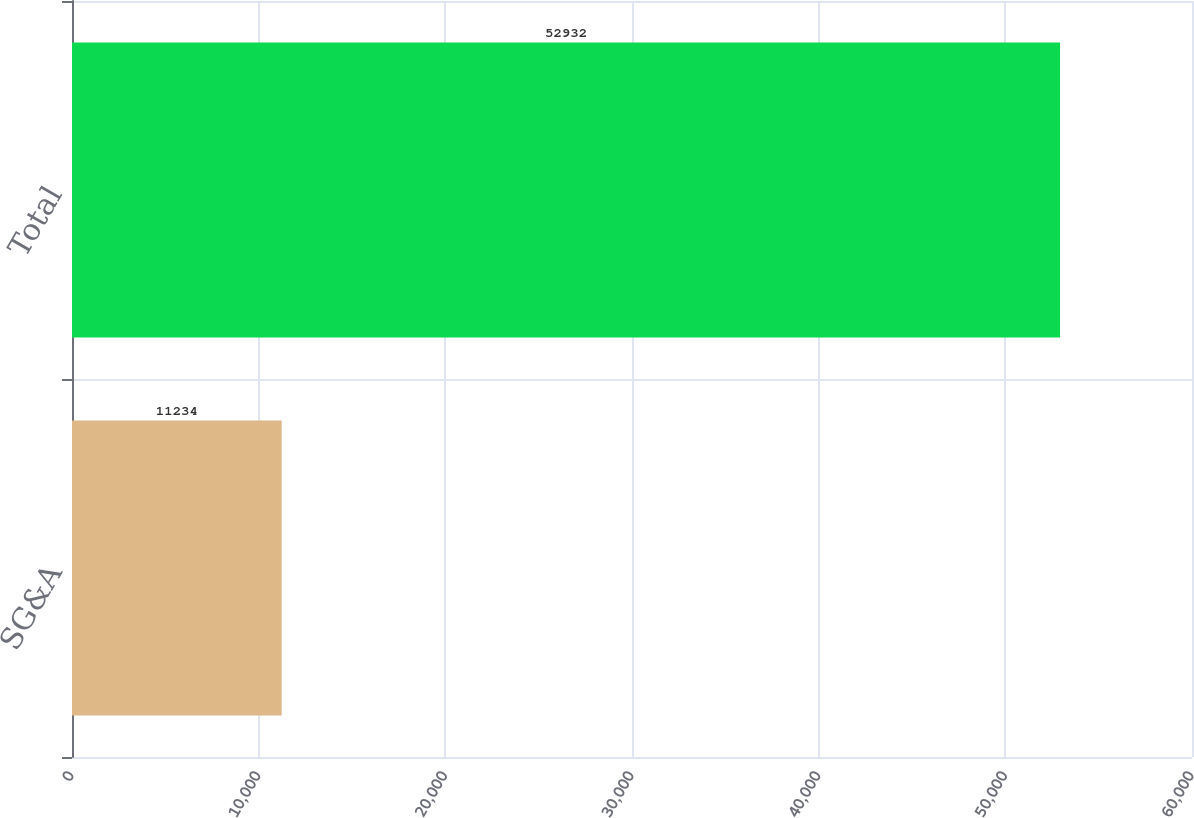Convert chart. <chart><loc_0><loc_0><loc_500><loc_500><bar_chart><fcel>SG&A<fcel>Total<nl><fcel>11234<fcel>52932<nl></chart> 